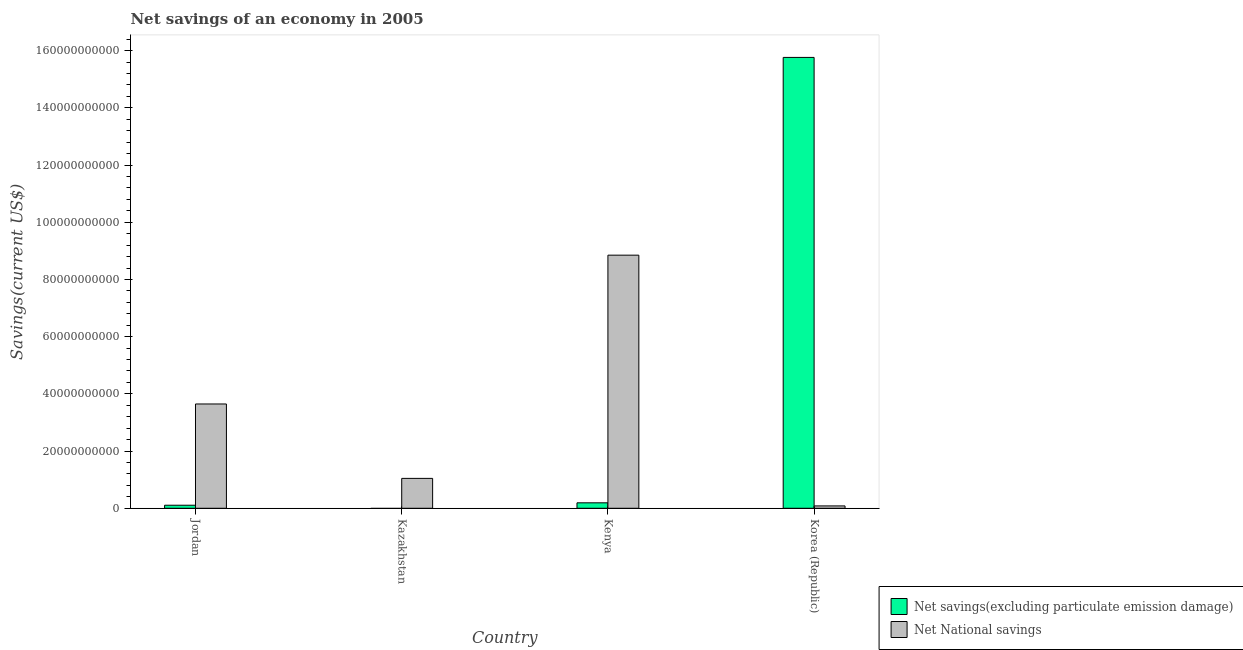Are the number of bars on each tick of the X-axis equal?
Provide a short and direct response. No. How many bars are there on the 4th tick from the left?
Offer a terse response. 2. How many bars are there on the 2nd tick from the right?
Ensure brevity in your answer.  2. In how many cases, is the number of bars for a given country not equal to the number of legend labels?
Make the answer very short. 1. What is the net national savings in Korea (Republic)?
Provide a short and direct response. 8.26e+08. Across all countries, what is the maximum net savings(excluding particulate emission damage)?
Offer a very short reply. 1.58e+11. Across all countries, what is the minimum net national savings?
Make the answer very short. 8.26e+08. In which country was the net national savings maximum?
Give a very brief answer. Kenya. What is the total net national savings in the graph?
Offer a terse response. 1.36e+11. What is the difference between the net national savings in Kazakhstan and that in Kenya?
Offer a very short reply. -7.81e+1. What is the difference between the net national savings in Kenya and the net savings(excluding particulate emission damage) in Jordan?
Your answer should be very brief. 8.74e+1. What is the average net national savings per country?
Your answer should be very brief. 3.41e+1. What is the difference between the net national savings and net savings(excluding particulate emission damage) in Kenya?
Offer a terse response. 8.66e+1. What is the ratio of the net savings(excluding particulate emission damage) in Jordan to that in Korea (Republic)?
Give a very brief answer. 0.01. What is the difference between the highest and the second highest net national savings?
Provide a succinct answer. 5.20e+1. What is the difference between the highest and the lowest net national savings?
Your answer should be compact. 8.77e+1. In how many countries, is the net national savings greater than the average net national savings taken over all countries?
Your answer should be very brief. 2. Are all the bars in the graph horizontal?
Provide a short and direct response. No. How many countries are there in the graph?
Your answer should be very brief. 4. What is the difference between two consecutive major ticks on the Y-axis?
Your answer should be compact. 2.00e+1. Are the values on the major ticks of Y-axis written in scientific E-notation?
Offer a terse response. No. Does the graph contain grids?
Give a very brief answer. No. How are the legend labels stacked?
Give a very brief answer. Vertical. What is the title of the graph?
Ensure brevity in your answer.  Net savings of an economy in 2005. What is the label or title of the X-axis?
Offer a very short reply. Country. What is the label or title of the Y-axis?
Provide a short and direct response. Savings(current US$). What is the Savings(current US$) of Net savings(excluding particulate emission damage) in Jordan?
Keep it short and to the point. 1.06e+09. What is the Savings(current US$) in Net National savings in Jordan?
Provide a short and direct response. 3.65e+1. What is the Savings(current US$) in Net savings(excluding particulate emission damage) in Kazakhstan?
Make the answer very short. 0. What is the Savings(current US$) of Net National savings in Kazakhstan?
Keep it short and to the point. 1.04e+1. What is the Savings(current US$) in Net savings(excluding particulate emission damage) in Kenya?
Ensure brevity in your answer.  1.91e+09. What is the Savings(current US$) in Net National savings in Kenya?
Provide a short and direct response. 8.85e+1. What is the Savings(current US$) in Net savings(excluding particulate emission damage) in Korea (Republic)?
Your response must be concise. 1.58e+11. What is the Savings(current US$) in Net National savings in Korea (Republic)?
Give a very brief answer. 8.26e+08. Across all countries, what is the maximum Savings(current US$) in Net savings(excluding particulate emission damage)?
Make the answer very short. 1.58e+11. Across all countries, what is the maximum Savings(current US$) in Net National savings?
Offer a terse response. 8.85e+1. Across all countries, what is the minimum Savings(current US$) of Net National savings?
Keep it short and to the point. 8.26e+08. What is the total Savings(current US$) of Net savings(excluding particulate emission damage) in the graph?
Keep it short and to the point. 1.61e+11. What is the total Savings(current US$) of Net National savings in the graph?
Provide a short and direct response. 1.36e+11. What is the difference between the Savings(current US$) of Net National savings in Jordan and that in Kazakhstan?
Keep it short and to the point. 2.60e+1. What is the difference between the Savings(current US$) in Net savings(excluding particulate emission damage) in Jordan and that in Kenya?
Offer a terse response. -8.45e+08. What is the difference between the Savings(current US$) of Net National savings in Jordan and that in Kenya?
Keep it short and to the point. -5.20e+1. What is the difference between the Savings(current US$) in Net savings(excluding particulate emission damage) in Jordan and that in Korea (Republic)?
Your response must be concise. -1.57e+11. What is the difference between the Savings(current US$) in Net National savings in Jordan and that in Korea (Republic)?
Your response must be concise. 3.56e+1. What is the difference between the Savings(current US$) of Net National savings in Kazakhstan and that in Kenya?
Provide a succinct answer. -7.81e+1. What is the difference between the Savings(current US$) of Net National savings in Kazakhstan and that in Korea (Republic)?
Offer a terse response. 9.62e+09. What is the difference between the Savings(current US$) in Net savings(excluding particulate emission damage) in Kenya and that in Korea (Republic)?
Your answer should be very brief. -1.56e+11. What is the difference between the Savings(current US$) of Net National savings in Kenya and that in Korea (Republic)?
Ensure brevity in your answer.  8.77e+1. What is the difference between the Savings(current US$) of Net savings(excluding particulate emission damage) in Jordan and the Savings(current US$) of Net National savings in Kazakhstan?
Give a very brief answer. -9.39e+09. What is the difference between the Savings(current US$) of Net savings(excluding particulate emission damage) in Jordan and the Savings(current US$) of Net National savings in Kenya?
Offer a terse response. -8.74e+1. What is the difference between the Savings(current US$) of Net savings(excluding particulate emission damage) in Jordan and the Savings(current US$) of Net National savings in Korea (Republic)?
Your answer should be compact. 2.36e+08. What is the difference between the Savings(current US$) in Net savings(excluding particulate emission damage) in Kenya and the Savings(current US$) in Net National savings in Korea (Republic)?
Your answer should be compact. 1.08e+09. What is the average Savings(current US$) in Net savings(excluding particulate emission damage) per country?
Offer a very short reply. 4.02e+1. What is the average Savings(current US$) in Net National savings per country?
Keep it short and to the point. 3.41e+1. What is the difference between the Savings(current US$) in Net savings(excluding particulate emission damage) and Savings(current US$) in Net National savings in Jordan?
Offer a very short reply. -3.54e+1. What is the difference between the Savings(current US$) of Net savings(excluding particulate emission damage) and Savings(current US$) of Net National savings in Kenya?
Your response must be concise. -8.66e+1. What is the difference between the Savings(current US$) in Net savings(excluding particulate emission damage) and Savings(current US$) in Net National savings in Korea (Republic)?
Offer a very short reply. 1.57e+11. What is the ratio of the Savings(current US$) of Net National savings in Jordan to that in Kazakhstan?
Give a very brief answer. 3.49. What is the ratio of the Savings(current US$) in Net savings(excluding particulate emission damage) in Jordan to that in Kenya?
Provide a succinct answer. 0.56. What is the ratio of the Savings(current US$) of Net National savings in Jordan to that in Kenya?
Keep it short and to the point. 0.41. What is the ratio of the Savings(current US$) in Net savings(excluding particulate emission damage) in Jordan to that in Korea (Republic)?
Your answer should be compact. 0.01. What is the ratio of the Savings(current US$) of Net National savings in Jordan to that in Korea (Republic)?
Your response must be concise. 44.15. What is the ratio of the Savings(current US$) of Net National savings in Kazakhstan to that in Kenya?
Make the answer very short. 0.12. What is the ratio of the Savings(current US$) of Net National savings in Kazakhstan to that in Korea (Republic)?
Provide a succinct answer. 12.65. What is the ratio of the Savings(current US$) in Net savings(excluding particulate emission damage) in Kenya to that in Korea (Republic)?
Give a very brief answer. 0.01. What is the ratio of the Savings(current US$) of Net National savings in Kenya to that in Korea (Republic)?
Offer a very short reply. 107.16. What is the difference between the highest and the second highest Savings(current US$) in Net savings(excluding particulate emission damage)?
Offer a very short reply. 1.56e+11. What is the difference between the highest and the second highest Savings(current US$) in Net National savings?
Give a very brief answer. 5.20e+1. What is the difference between the highest and the lowest Savings(current US$) of Net savings(excluding particulate emission damage)?
Your answer should be very brief. 1.58e+11. What is the difference between the highest and the lowest Savings(current US$) of Net National savings?
Ensure brevity in your answer.  8.77e+1. 